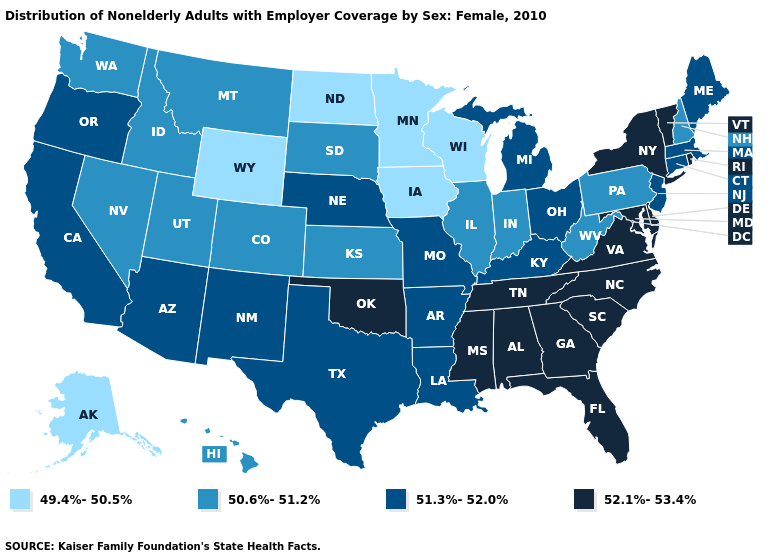Is the legend a continuous bar?
Concise answer only. No. Which states hav the highest value in the West?
Answer briefly. Arizona, California, New Mexico, Oregon. Does North Dakota have the lowest value in the USA?
Quick response, please. Yes. What is the value of Minnesota?
Concise answer only. 49.4%-50.5%. Does Missouri have a higher value than Florida?
Quick response, please. No. What is the value of Virginia?
Write a very short answer. 52.1%-53.4%. What is the value of Illinois?
Short answer required. 50.6%-51.2%. What is the lowest value in states that border Connecticut?
Give a very brief answer. 51.3%-52.0%. What is the value of Iowa?
Answer briefly. 49.4%-50.5%. What is the highest value in the South ?
Concise answer only. 52.1%-53.4%. What is the highest value in states that border Colorado?
Answer briefly. 52.1%-53.4%. What is the value of Missouri?
Short answer required. 51.3%-52.0%. What is the value of Idaho?
Keep it brief. 50.6%-51.2%. Name the states that have a value in the range 52.1%-53.4%?
Short answer required. Alabama, Delaware, Florida, Georgia, Maryland, Mississippi, New York, North Carolina, Oklahoma, Rhode Island, South Carolina, Tennessee, Vermont, Virginia. What is the value of Kentucky?
Short answer required. 51.3%-52.0%. 